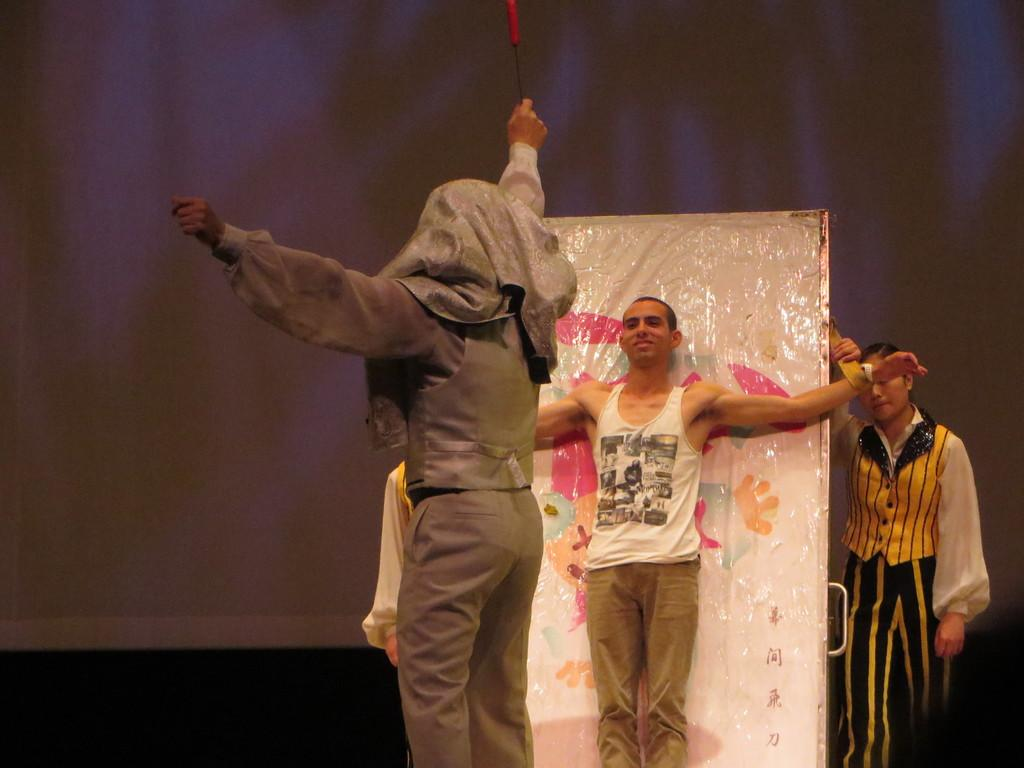What is the main focus of the image? The main focus of the image is the persons in the center. Can you describe the setting or environment in the image? There is a screen in the background of the image. What type of bread is being used to provide comfort to the persons in the image? There is no bread present in the image, and no indication of comfort being provided. 